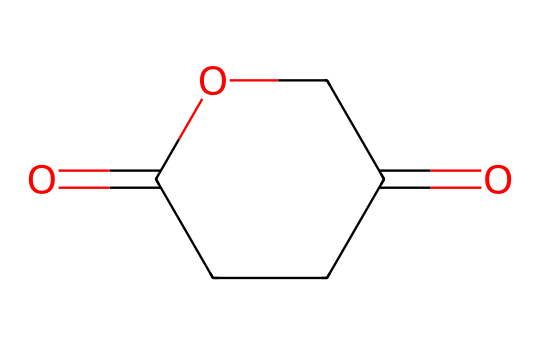What is the name of this chemical? The SMILES representation corresponds to a chemical structure known as glutaric anhydride, which is derived from glutaric acid by the removal of water between carboxylic groups.
Answer: glutaric anhydride How many carbon atoms are present in glutaric anhydride? By analyzing the SMILES representation, we see there are five 'C' (carbon) symbols indicating five carbon atoms in the structure.
Answer: five What functional groups are present in this compound? The structure indicates the presence of an anhydride functional group, which consists of carbonyls and an ether linkage, specifically the cyclic form here.
Answer: anhydride How many oxygen atoms does glutaric anhydride contain? The SMILES notation shows two 'O' (oxygen) symbols, meaning there are two oxygen atoms in the structure of glutaric anhydride.
Answer: two Is glutaric anhydride an acid or base? The presence of the anhydride functional group makes it acidic because it can release protons in solution, characteristic of acid anhydrides.
Answer: acid What type of chemical is glutaric anhydride classified as? Glutaric anhydride belongs to the category of acid anhydrides, which are derived from acids and lack a water molecule.
Answer: acid anhydride 